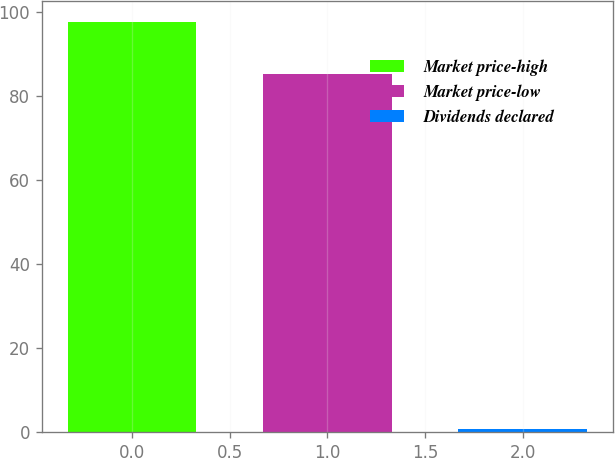Convert chart. <chart><loc_0><loc_0><loc_500><loc_500><bar_chart><fcel>Market price-high<fcel>Market price-low<fcel>Dividends declared<nl><fcel>97.77<fcel>85.41<fcel>0.6<nl></chart> 